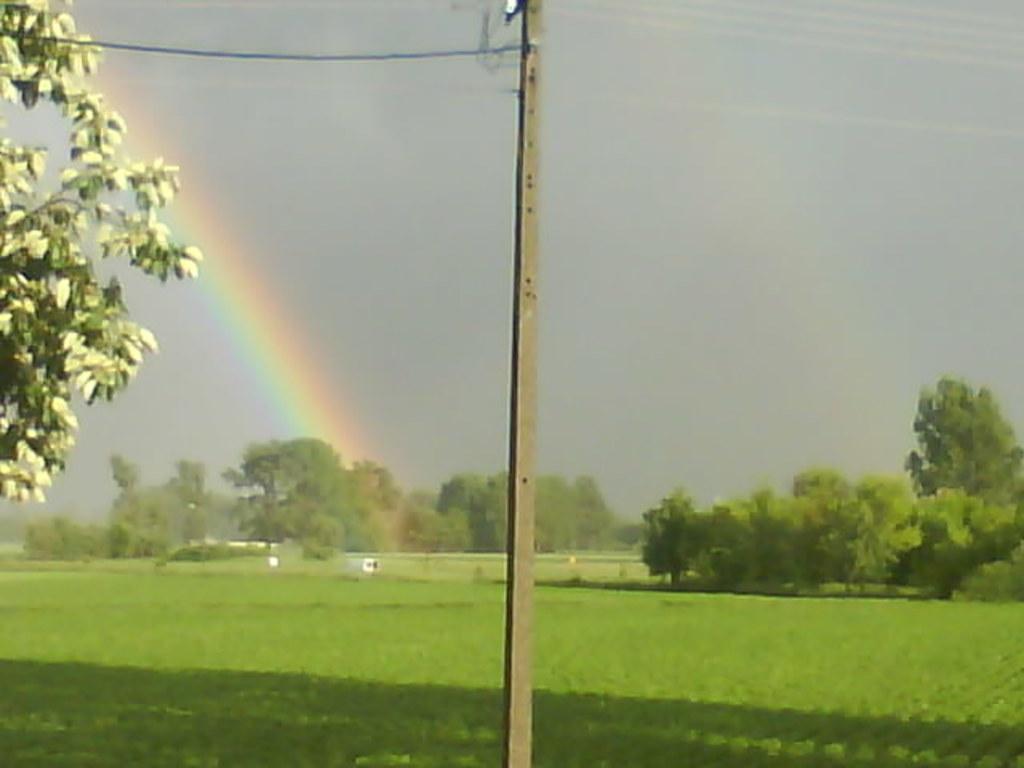Can you describe this image briefly? In this picture we can see an electric pole with cables. Behind the pole there is a rainbow, fields, trees and the sky. 